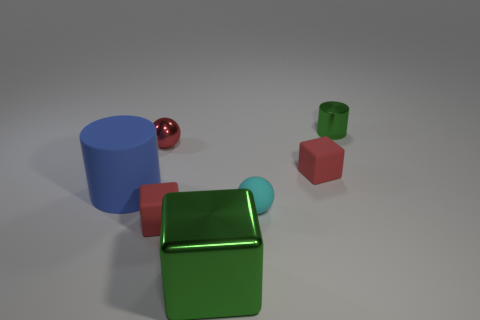What number of gray things are either large objects or tiny matte cylinders?
Your answer should be compact. 0. Is the number of red spheres greater than the number of red matte things?
Provide a short and direct response. No. How many things are cubes that are in front of the large blue object or red objects in front of the tiny red ball?
Give a very brief answer. 3. The matte cylinder that is the same size as the green cube is what color?
Provide a succinct answer. Blue. Do the small green thing and the large green object have the same material?
Provide a succinct answer. Yes. What is the material of the green thing that is behind the cube behind the blue thing?
Keep it short and to the point. Metal. Is the number of large metal blocks that are to the left of the tiny green cylinder greater than the number of brown metallic things?
Keep it short and to the point. Yes. How many other objects are the same size as the metal cylinder?
Ensure brevity in your answer.  4. Is the small metal cylinder the same color as the metallic cube?
Keep it short and to the point. Yes. What is the color of the cylinder that is to the left of the shiny object behind the small metallic object that is to the left of the green cylinder?
Make the answer very short. Blue. 